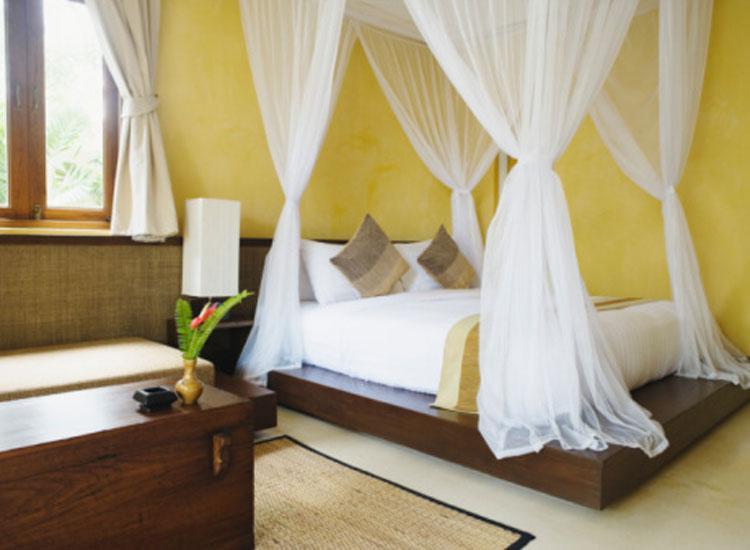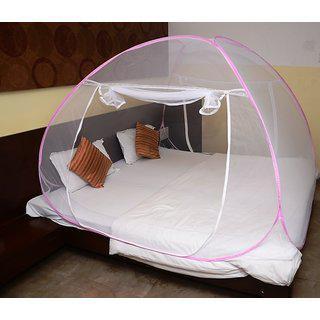The first image is the image on the left, the second image is the image on the right. Analyze the images presented: Is the assertion "There is a bed with canopy netting tied at each of four corners." valid? Answer yes or no. Yes. 